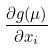<formula> <loc_0><loc_0><loc_500><loc_500>\frac { \partial g ( \mu ) } { \partial x _ { i } }</formula> 